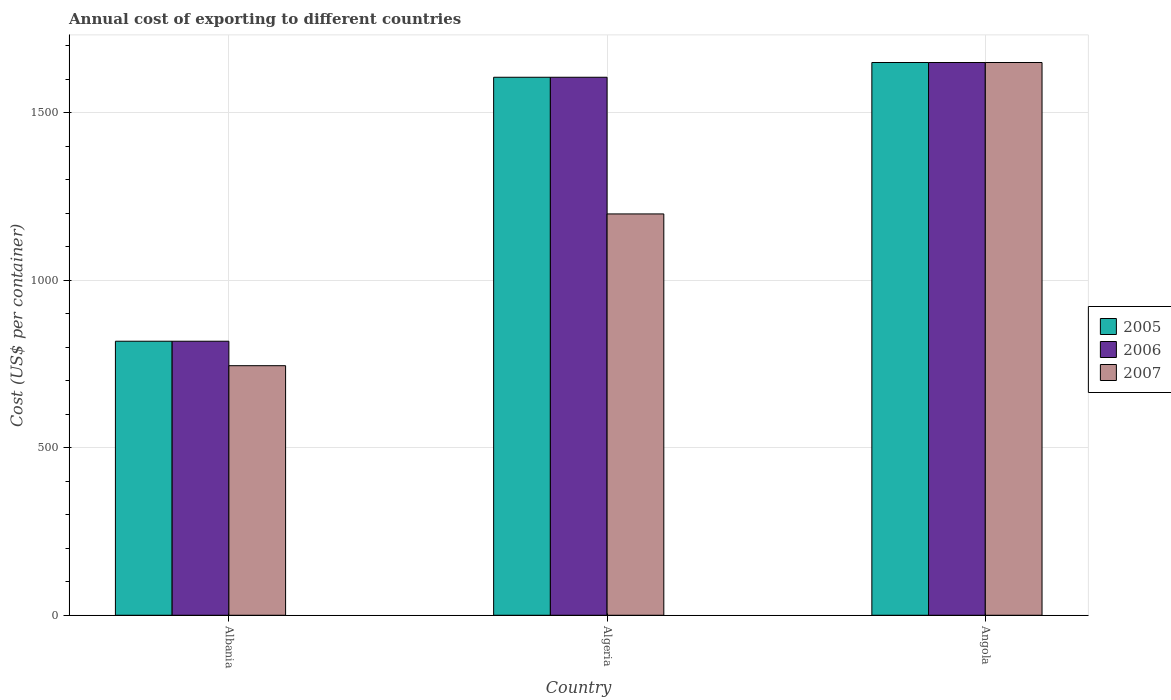How many groups of bars are there?
Make the answer very short. 3. Are the number of bars per tick equal to the number of legend labels?
Provide a short and direct response. Yes. Are the number of bars on each tick of the X-axis equal?
Your answer should be compact. Yes. How many bars are there on the 1st tick from the left?
Offer a terse response. 3. How many bars are there on the 2nd tick from the right?
Your answer should be very brief. 3. What is the label of the 2nd group of bars from the left?
Your answer should be compact. Algeria. What is the total annual cost of exporting in 2005 in Albania?
Your answer should be compact. 818. Across all countries, what is the maximum total annual cost of exporting in 2005?
Your response must be concise. 1650. Across all countries, what is the minimum total annual cost of exporting in 2006?
Your response must be concise. 818. In which country was the total annual cost of exporting in 2005 maximum?
Make the answer very short. Angola. In which country was the total annual cost of exporting in 2005 minimum?
Offer a terse response. Albania. What is the total total annual cost of exporting in 2007 in the graph?
Your answer should be compact. 3593. What is the difference between the total annual cost of exporting in 2005 in Algeria and that in Angola?
Your answer should be very brief. -44. What is the difference between the total annual cost of exporting in 2005 in Algeria and the total annual cost of exporting in 2007 in Albania?
Ensure brevity in your answer.  861. What is the average total annual cost of exporting in 2006 per country?
Give a very brief answer. 1358. What is the difference between the total annual cost of exporting of/in 2005 and total annual cost of exporting of/in 2007 in Angola?
Keep it short and to the point. 0. In how many countries, is the total annual cost of exporting in 2007 greater than 1100 US$?
Make the answer very short. 2. What is the ratio of the total annual cost of exporting in 2005 in Albania to that in Algeria?
Keep it short and to the point. 0.51. What is the difference between the highest and the second highest total annual cost of exporting in 2007?
Give a very brief answer. -905. What is the difference between the highest and the lowest total annual cost of exporting in 2006?
Your response must be concise. 832. Is the sum of the total annual cost of exporting in 2005 in Algeria and Angola greater than the maximum total annual cost of exporting in 2007 across all countries?
Keep it short and to the point. Yes. Is it the case that in every country, the sum of the total annual cost of exporting in 2006 and total annual cost of exporting in 2005 is greater than the total annual cost of exporting in 2007?
Provide a succinct answer. Yes. How many bars are there?
Provide a short and direct response. 9. How many countries are there in the graph?
Ensure brevity in your answer.  3. Are the values on the major ticks of Y-axis written in scientific E-notation?
Your response must be concise. No. Where does the legend appear in the graph?
Your answer should be very brief. Center right. How many legend labels are there?
Offer a very short reply. 3. What is the title of the graph?
Make the answer very short. Annual cost of exporting to different countries. Does "1995" appear as one of the legend labels in the graph?
Give a very brief answer. No. What is the label or title of the Y-axis?
Your response must be concise. Cost (US$ per container). What is the Cost (US$ per container) in 2005 in Albania?
Keep it short and to the point. 818. What is the Cost (US$ per container) of 2006 in Albania?
Your answer should be compact. 818. What is the Cost (US$ per container) in 2007 in Albania?
Keep it short and to the point. 745. What is the Cost (US$ per container) of 2005 in Algeria?
Your response must be concise. 1606. What is the Cost (US$ per container) of 2006 in Algeria?
Make the answer very short. 1606. What is the Cost (US$ per container) in 2007 in Algeria?
Ensure brevity in your answer.  1198. What is the Cost (US$ per container) in 2005 in Angola?
Give a very brief answer. 1650. What is the Cost (US$ per container) in 2006 in Angola?
Provide a succinct answer. 1650. What is the Cost (US$ per container) of 2007 in Angola?
Your response must be concise. 1650. Across all countries, what is the maximum Cost (US$ per container) of 2005?
Offer a very short reply. 1650. Across all countries, what is the maximum Cost (US$ per container) in 2006?
Keep it short and to the point. 1650. Across all countries, what is the maximum Cost (US$ per container) in 2007?
Provide a succinct answer. 1650. Across all countries, what is the minimum Cost (US$ per container) of 2005?
Offer a terse response. 818. Across all countries, what is the minimum Cost (US$ per container) of 2006?
Give a very brief answer. 818. Across all countries, what is the minimum Cost (US$ per container) of 2007?
Provide a succinct answer. 745. What is the total Cost (US$ per container) of 2005 in the graph?
Offer a terse response. 4074. What is the total Cost (US$ per container) in 2006 in the graph?
Your answer should be compact. 4074. What is the total Cost (US$ per container) of 2007 in the graph?
Your answer should be very brief. 3593. What is the difference between the Cost (US$ per container) in 2005 in Albania and that in Algeria?
Provide a short and direct response. -788. What is the difference between the Cost (US$ per container) in 2006 in Albania and that in Algeria?
Keep it short and to the point. -788. What is the difference between the Cost (US$ per container) in 2007 in Albania and that in Algeria?
Offer a very short reply. -453. What is the difference between the Cost (US$ per container) of 2005 in Albania and that in Angola?
Provide a short and direct response. -832. What is the difference between the Cost (US$ per container) of 2006 in Albania and that in Angola?
Offer a very short reply. -832. What is the difference between the Cost (US$ per container) of 2007 in Albania and that in Angola?
Give a very brief answer. -905. What is the difference between the Cost (US$ per container) in 2005 in Algeria and that in Angola?
Your answer should be compact. -44. What is the difference between the Cost (US$ per container) in 2006 in Algeria and that in Angola?
Your answer should be very brief. -44. What is the difference between the Cost (US$ per container) of 2007 in Algeria and that in Angola?
Keep it short and to the point. -452. What is the difference between the Cost (US$ per container) in 2005 in Albania and the Cost (US$ per container) in 2006 in Algeria?
Your answer should be very brief. -788. What is the difference between the Cost (US$ per container) of 2005 in Albania and the Cost (US$ per container) of 2007 in Algeria?
Your answer should be compact. -380. What is the difference between the Cost (US$ per container) of 2006 in Albania and the Cost (US$ per container) of 2007 in Algeria?
Provide a succinct answer. -380. What is the difference between the Cost (US$ per container) in 2005 in Albania and the Cost (US$ per container) in 2006 in Angola?
Your response must be concise. -832. What is the difference between the Cost (US$ per container) in 2005 in Albania and the Cost (US$ per container) in 2007 in Angola?
Your answer should be very brief. -832. What is the difference between the Cost (US$ per container) of 2006 in Albania and the Cost (US$ per container) of 2007 in Angola?
Offer a very short reply. -832. What is the difference between the Cost (US$ per container) in 2005 in Algeria and the Cost (US$ per container) in 2006 in Angola?
Your answer should be very brief. -44. What is the difference between the Cost (US$ per container) of 2005 in Algeria and the Cost (US$ per container) of 2007 in Angola?
Keep it short and to the point. -44. What is the difference between the Cost (US$ per container) in 2006 in Algeria and the Cost (US$ per container) in 2007 in Angola?
Your answer should be compact. -44. What is the average Cost (US$ per container) in 2005 per country?
Your answer should be compact. 1358. What is the average Cost (US$ per container) in 2006 per country?
Offer a very short reply. 1358. What is the average Cost (US$ per container) in 2007 per country?
Your answer should be compact. 1197.67. What is the difference between the Cost (US$ per container) in 2005 and Cost (US$ per container) in 2007 in Albania?
Your response must be concise. 73. What is the difference between the Cost (US$ per container) in 2006 and Cost (US$ per container) in 2007 in Albania?
Your answer should be very brief. 73. What is the difference between the Cost (US$ per container) of 2005 and Cost (US$ per container) of 2007 in Algeria?
Make the answer very short. 408. What is the difference between the Cost (US$ per container) in 2006 and Cost (US$ per container) in 2007 in Algeria?
Offer a terse response. 408. What is the difference between the Cost (US$ per container) of 2005 and Cost (US$ per container) of 2006 in Angola?
Your answer should be very brief. 0. What is the difference between the Cost (US$ per container) in 2005 and Cost (US$ per container) in 2007 in Angola?
Provide a short and direct response. 0. What is the ratio of the Cost (US$ per container) of 2005 in Albania to that in Algeria?
Offer a terse response. 0.51. What is the ratio of the Cost (US$ per container) of 2006 in Albania to that in Algeria?
Your answer should be very brief. 0.51. What is the ratio of the Cost (US$ per container) of 2007 in Albania to that in Algeria?
Ensure brevity in your answer.  0.62. What is the ratio of the Cost (US$ per container) of 2005 in Albania to that in Angola?
Your answer should be very brief. 0.5. What is the ratio of the Cost (US$ per container) of 2006 in Albania to that in Angola?
Your response must be concise. 0.5. What is the ratio of the Cost (US$ per container) in 2007 in Albania to that in Angola?
Provide a succinct answer. 0.45. What is the ratio of the Cost (US$ per container) of 2005 in Algeria to that in Angola?
Ensure brevity in your answer.  0.97. What is the ratio of the Cost (US$ per container) in 2006 in Algeria to that in Angola?
Offer a very short reply. 0.97. What is the ratio of the Cost (US$ per container) in 2007 in Algeria to that in Angola?
Give a very brief answer. 0.73. What is the difference between the highest and the second highest Cost (US$ per container) in 2006?
Provide a succinct answer. 44. What is the difference between the highest and the second highest Cost (US$ per container) in 2007?
Provide a succinct answer. 452. What is the difference between the highest and the lowest Cost (US$ per container) in 2005?
Offer a very short reply. 832. What is the difference between the highest and the lowest Cost (US$ per container) of 2006?
Ensure brevity in your answer.  832. What is the difference between the highest and the lowest Cost (US$ per container) of 2007?
Make the answer very short. 905. 